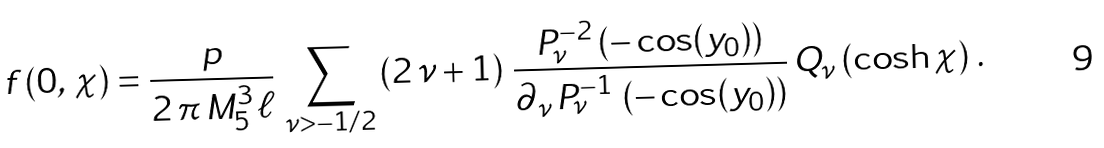Convert formula to latex. <formula><loc_0><loc_0><loc_500><loc_500>f \left ( 0 , \, \chi \right ) = \frac { p } { 2 \, \pi \, M ^ { 3 } _ { 5 } \, \ell } \, \sum _ { \nu > - 1 / 2 } \left ( 2 \, \nu + 1 \right ) \, \frac { P _ { \nu } ^ { - 2 } \left ( - \cos ( y _ { 0 } ) \right ) } { \partial _ { \nu } \, P _ { \nu } ^ { - 1 } \, \left ( - \cos ( y _ { 0 } ) \right ) } \, Q _ { \nu } \left ( \cosh \chi \right ) \, .</formula> 